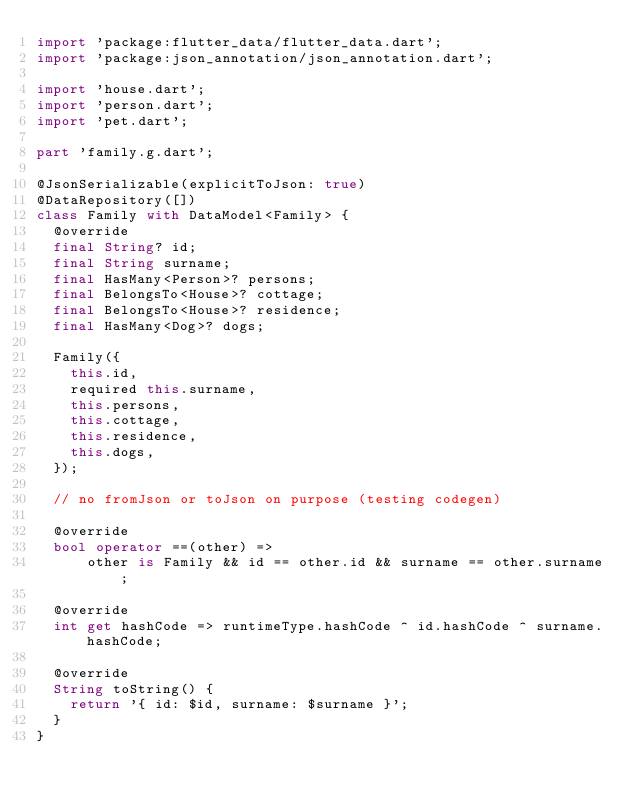Convert code to text. <code><loc_0><loc_0><loc_500><loc_500><_Dart_>import 'package:flutter_data/flutter_data.dart';
import 'package:json_annotation/json_annotation.dart';

import 'house.dart';
import 'person.dart';
import 'pet.dart';

part 'family.g.dart';

@JsonSerializable(explicitToJson: true)
@DataRepository([])
class Family with DataModel<Family> {
  @override
  final String? id;
  final String surname;
  final HasMany<Person>? persons;
  final BelongsTo<House>? cottage;
  final BelongsTo<House>? residence;
  final HasMany<Dog>? dogs;

  Family({
    this.id,
    required this.surname,
    this.persons,
    this.cottage,
    this.residence,
    this.dogs,
  });

  // no fromJson or toJson on purpose (testing codegen)

  @override
  bool operator ==(other) =>
      other is Family && id == other.id && surname == other.surname;

  @override
  int get hashCode => runtimeType.hashCode ^ id.hashCode ^ surname.hashCode;

  @override
  String toString() {
    return '{ id: $id, surname: $surname }';
  }
}
</code> 